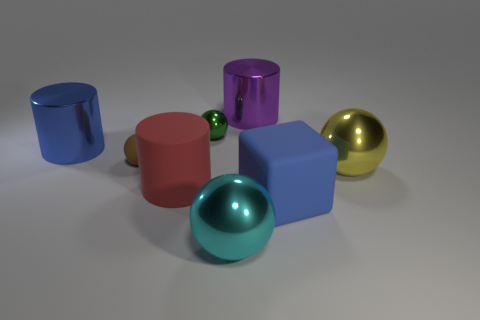Subtract all big red matte cylinders. How many cylinders are left? 2 Add 1 small green spheres. How many objects exist? 9 Subtract all purple cylinders. How many cylinders are left? 2 Subtract all blocks. How many objects are left? 7 Subtract 1 cubes. How many cubes are left? 0 Subtract all gray cylinders. How many cyan balls are left? 1 Add 4 metal objects. How many metal objects exist? 9 Subtract 1 yellow spheres. How many objects are left? 7 Subtract all yellow cylinders. Subtract all blue blocks. How many cylinders are left? 3 Subtract all big metal cubes. Subtract all large yellow spheres. How many objects are left? 7 